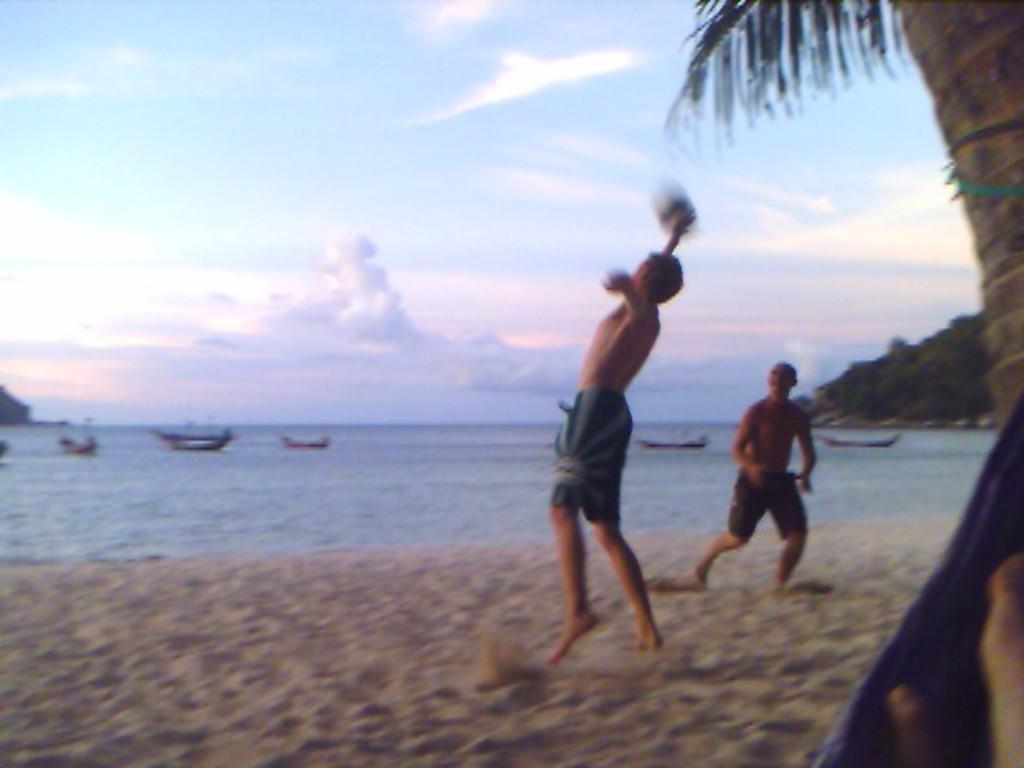Can you describe this image briefly? In this picture we can see few people, beside to the we can find a tree, in the background we can see few boats on the water, clouds and trees. 